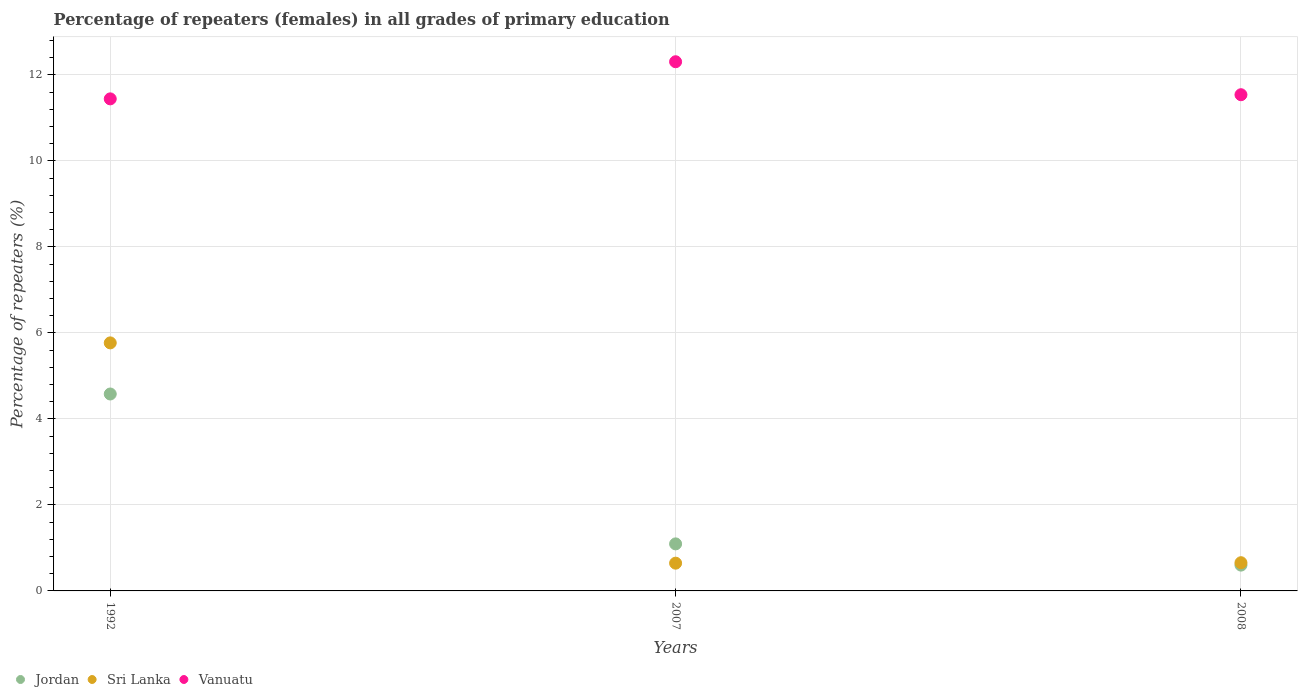How many different coloured dotlines are there?
Keep it short and to the point. 3. Is the number of dotlines equal to the number of legend labels?
Provide a succinct answer. Yes. What is the percentage of repeaters (females) in Jordan in 2007?
Ensure brevity in your answer.  1.09. Across all years, what is the maximum percentage of repeaters (females) in Sri Lanka?
Offer a very short reply. 5.77. Across all years, what is the minimum percentage of repeaters (females) in Jordan?
Provide a short and direct response. 0.6. What is the total percentage of repeaters (females) in Sri Lanka in the graph?
Offer a terse response. 7.07. What is the difference between the percentage of repeaters (females) in Sri Lanka in 1992 and that in 2008?
Your answer should be very brief. 5.11. What is the difference between the percentage of repeaters (females) in Jordan in 2007 and the percentage of repeaters (females) in Vanuatu in 2008?
Offer a very short reply. -10.44. What is the average percentage of repeaters (females) in Vanuatu per year?
Keep it short and to the point. 11.76. In the year 2007, what is the difference between the percentage of repeaters (females) in Sri Lanka and percentage of repeaters (females) in Jordan?
Offer a very short reply. -0.45. In how many years, is the percentage of repeaters (females) in Vanuatu greater than 10.4 %?
Provide a short and direct response. 3. What is the ratio of the percentage of repeaters (females) in Jordan in 2007 to that in 2008?
Offer a very short reply. 1.82. Is the difference between the percentage of repeaters (females) in Sri Lanka in 1992 and 2008 greater than the difference between the percentage of repeaters (females) in Jordan in 1992 and 2008?
Give a very brief answer. Yes. What is the difference between the highest and the second highest percentage of repeaters (females) in Jordan?
Make the answer very short. 3.49. What is the difference between the highest and the lowest percentage of repeaters (females) in Vanuatu?
Provide a short and direct response. 0.86. In how many years, is the percentage of repeaters (females) in Jordan greater than the average percentage of repeaters (females) in Jordan taken over all years?
Provide a short and direct response. 1. Is the sum of the percentage of repeaters (females) in Vanuatu in 2007 and 2008 greater than the maximum percentage of repeaters (females) in Jordan across all years?
Provide a succinct answer. Yes. Is it the case that in every year, the sum of the percentage of repeaters (females) in Vanuatu and percentage of repeaters (females) in Jordan  is greater than the percentage of repeaters (females) in Sri Lanka?
Your answer should be very brief. Yes. Is the percentage of repeaters (females) in Vanuatu strictly less than the percentage of repeaters (females) in Sri Lanka over the years?
Your answer should be compact. No. How many dotlines are there?
Your response must be concise. 3. What is the difference between two consecutive major ticks on the Y-axis?
Provide a succinct answer. 2. Does the graph contain any zero values?
Offer a terse response. No. Does the graph contain grids?
Your response must be concise. Yes. What is the title of the graph?
Give a very brief answer. Percentage of repeaters (females) in all grades of primary education. Does "Cayman Islands" appear as one of the legend labels in the graph?
Provide a succinct answer. No. What is the label or title of the Y-axis?
Make the answer very short. Percentage of repeaters (%). What is the Percentage of repeaters (%) in Jordan in 1992?
Offer a terse response. 4.58. What is the Percentage of repeaters (%) of Sri Lanka in 1992?
Ensure brevity in your answer.  5.77. What is the Percentage of repeaters (%) in Vanuatu in 1992?
Your response must be concise. 11.44. What is the Percentage of repeaters (%) in Jordan in 2007?
Give a very brief answer. 1.09. What is the Percentage of repeaters (%) in Sri Lanka in 2007?
Keep it short and to the point. 0.65. What is the Percentage of repeaters (%) of Vanuatu in 2007?
Offer a terse response. 12.31. What is the Percentage of repeaters (%) in Jordan in 2008?
Your response must be concise. 0.6. What is the Percentage of repeaters (%) of Sri Lanka in 2008?
Your answer should be compact. 0.66. What is the Percentage of repeaters (%) of Vanuatu in 2008?
Your answer should be very brief. 11.54. Across all years, what is the maximum Percentage of repeaters (%) of Jordan?
Provide a succinct answer. 4.58. Across all years, what is the maximum Percentage of repeaters (%) in Sri Lanka?
Offer a terse response. 5.77. Across all years, what is the maximum Percentage of repeaters (%) in Vanuatu?
Give a very brief answer. 12.31. Across all years, what is the minimum Percentage of repeaters (%) in Jordan?
Your answer should be very brief. 0.6. Across all years, what is the minimum Percentage of repeaters (%) of Sri Lanka?
Offer a terse response. 0.65. Across all years, what is the minimum Percentage of repeaters (%) of Vanuatu?
Offer a very short reply. 11.44. What is the total Percentage of repeaters (%) in Jordan in the graph?
Make the answer very short. 6.27. What is the total Percentage of repeaters (%) in Sri Lanka in the graph?
Your answer should be compact. 7.07. What is the total Percentage of repeaters (%) in Vanuatu in the graph?
Offer a terse response. 35.29. What is the difference between the Percentage of repeaters (%) of Jordan in 1992 and that in 2007?
Give a very brief answer. 3.49. What is the difference between the Percentage of repeaters (%) of Sri Lanka in 1992 and that in 2007?
Provide a succinct answer. 5.12. What is the difference between the Percentage of repeaters (%) in Vanuatu in 1992 and that in 2007?
Make the answer very short. -0.86. What is the difference between the Percentage of repeaters (%) of Jordan in 1992 and that in 2008?
Provide a short and direct response. 3.98. What is the difference between the Percentage of repeaters (%) of Sri Lanka in 1992 and that in 2008?
Make the answer very short. 5.11. What is the difference between the Percentage of repeaters (%) in Vanuatu in 1992 and that in 2008?
Offer a very short reply. -0.1. What is the difference between the Percentage of repeaters (%) of Jordan in 2007 and that in 2008?
Make the answer very short. 0.49. What is the difference between the Percentage of repeaters (%) of Sri Lanka in 2007 and that in 2008?
Ensure brevity in your answer.  -0.01. What is the difference between the Percentage of repeaters (%) in Vanuatu in 2007 and that in 2008?
Give a very brief answer. 0.77. What is the difference between the Percentage of repeaters (%) in Jordan in 1992 and the Percentage of repeaters (%) in Sri Lanka in 2007?
Provide a succinct answer. 3.93. What is the difference between the Percentage of repeaters (%) of Jordan in 1992 and the Percentage of repeaters (%) of Vanuatu in 2007?
Offer a very short reply. -7.73. What is the difference between the Percentage of repeaters (%) of Sri Lanka in 1992 and the Percentage of repeaters (%) of Vanuatu in 2007?
Make the answer very short. -6.54. What is the difference between the Percentage of repeaters (%) in Jordan in 1992 and the Percentage of repeaters (%) in Sri Lanka in 2008?
Give a very brief answer. 3.92. What is the difference between the Percentage of repeaters (%) in Jordan in 1992 and the Percentage of repeaters (%) in Vanuatu in 2008?
Provide a short and direct response. -6.96. What is the difference between the Percentage of repeaters (%) in Sri Lanka in 1992 and the Percentage of repeaters (%) in Vanuatu in 2008?
Your answer should be very brief. -5.77. What is the difference between the Percentage of repeaters (%) in Jordan in 2007 and the Percentage of repeaters (%) in Sri Lanka in 2008?
Ensure brevity in your answer.  0.44. What is the difference between the Percentage of repeaters (%) of Jordan in 2007 and the Percentage of repeaters (%) of Vanuatu in 2008?
Your answer should be compact. -10.44. What is the difference between the Percentage of repeaters (%) in Sri Lanka in 2007 and the Percentage of repeaters (%) in Vanuatu in 2008?
Provide a succinct answer. -10.89. What is the average Percentage of repeaters (%) of Jordan per year?
Provide a short and direct response. 2.09. What is the average Percentage of repeaters (%) in Sri Lanka per year?
Offer a terse response. 2.36. What is the average Percentage of repeaters (%) in Vanuatu per year?
Make the answer very short. 11.76. In the year 1992, what is the difference between the Percentage of repeaters (%) in Jordan and Percentage of repeaters (%) in Sri Lanka?
Your answer should be very brief. -1.19. In the year 1992, what is the difference between the Percentage of repeaters (%) of Jordan and Percentage of repeaters (%) of Vanuatu?
Provide a succinct answer. -6.86. In the year 1992, what is the difference between the Percentage of repeaters (%) in Sri Lanka and Percentage of repeaters (%) in Vanuatu?
Your answer should be compact. -5.67. In the year 2007, what is the difference between the Percentage of repeaters (%) of Jordan and Percentage of repeaters (%) of Sri Lanka?
Make the answer very short. 0.45. In the year 2007, what is the difference between the Percentage of repeaters (%) in Jordan and Percentage of repeaters (%) in Vanuatu?
Offer a terse response. -11.21. In the year 2007, what is the difference between the Percentage of repeaters (%) of Sri Lanka and Percentage of repeaters (%) of Vanuatu?
Your answer should be compact. -11.66. In the year 2008, what is the difference between the Percentage of repeaters (%) in Jordan and Percentage of repeaters (%) in Sri Lanka?
Provide a short and direct response. -0.06. In the year 2008, what is the difference between the Percentage of repeaters (%) in Jordan and Percentage of repeaters (%) in Vanuatu?
Your answer should be compact. -10.94. In the year 2008, what is the difference between the Percentage of repeaters (%) in Sri Lanka and Percentage of repeaters (%) in Vanuatu?
Make the answer very short. -10.88. What is the ratio of the Percentage of repeaters (%) of Jordan in 1992 to that in 2007?
Your answer should be compact. 4.19. What is the ratio of the Percentage of repeaters (%) in Sri Lanka in 1992 to that in 2007?
Keep it short and to the point. 8.94. What is the ratio of the Percentage of repeaters (%) of Vanuatu in 1992 to that in 2007?
Give a very brief answer. 0.93. What is the ratio of the Percentage of repeaters (%) in Jordan in 1992 to that in 2008?
Offer a terse response. 7.63. What is the ratio of the Percentage of repeaters (%) of Sri Lanka in 1992 to that in 2008?
Your response must be concise. 8.79. What is the ratio of the Percentage of repeaters (%) of Vanuatu in 1992 to that in 2008?
Your answer should be very brief. 0.99. What is the ratio of the Percentage of repeaters (%) in Jordan in 2007 to that in 2008?
Offer a very short reply. 1.82. What is the ratio of the Percentage of repeaters (%) in Sri Lanka in 2007 to that in 2008?
Offer a very short reply. 0.98. What is the ratio of the Percentage of repeaters (%) of Vanuatu in 2007 to that in 2008?
Give a very brief answer. 1.07. What is the difference between the highest and the second highest Percentage of repeaters (%) in Jordan?
Provide a succinct answer. 3.49. What is the difference between the highest and the second highest Percentage of repeaters (%) of Sri Lanka?
Your answer should be very brief. 5.11. What is the difference between the highest and the second highest Percentage of repeaters (%) in Vanuatu?
Give a very brief answer. 0.77. What is the difference between the highest and the lowest Percentage of repeaters (%) of Jordan?
Your answer should be very brief. 3.98. What is the difference between the highest and the lowest Percentage of repeaters (%) in Sri Lanka?
Offer a terse response. 5.12. What is the difference between the highest and the lowest Percentage of repeaters (%) of Vanuatu?
Offer a very short reply. 0.86. 